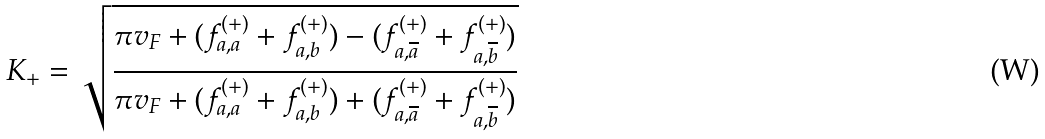Convert formula to latex. <formula><loc_0><loc_0><loc_500><loc_500>K _ { + } = \sqrt { \frac { \pi v _ { F } + ( f ^ { ( + ) } _ { a , a } + f ^ { ( + ) } _ { a , b } ) - ( f ^ { ( + ) } _ { a , \overline { a } } + f ^ { ( + ) } _ { a , \overline { b } } ) } { \pi v _ { F } + ( f ^ { ( + ) } _ { a , a } + f ^ { ( + ) } _ { a , b } ) + ( f ^ { ( + ) } _ { a , \overline { a } } + f ^ { ( + ) } _ { a , \overline { b } } ) } }</formula> 